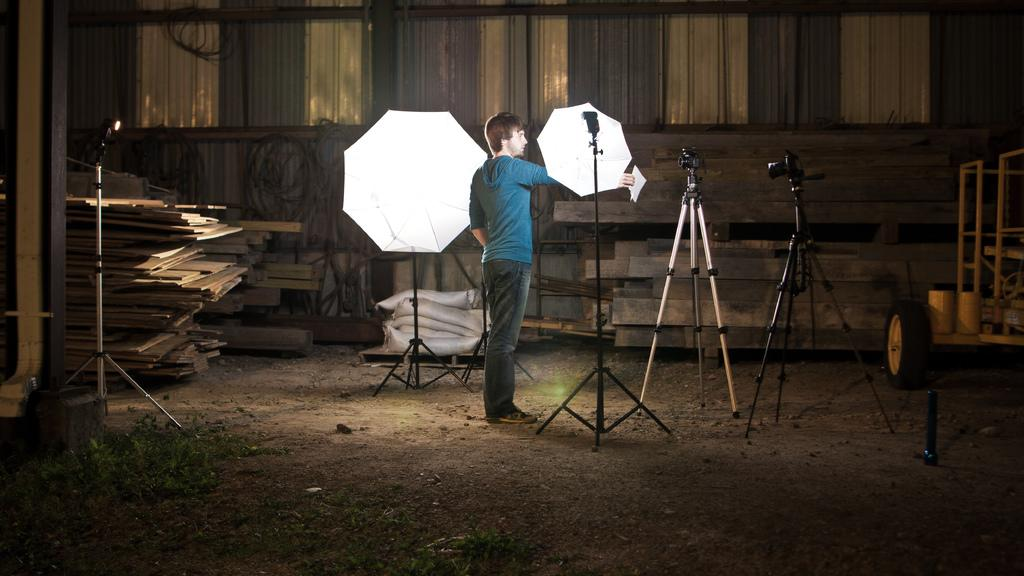What is the main subject of the image? There is a man standing in the image. What is the man wearing? The man is wearing clothes. What objects related to photography can be seen in the image? There are cameras, a stand, and a flash diffuser umbrella in the image. What type of surface is visible in the image? There are wooden sheets, grass, and sand in the image. What other objects can be seen in the image? There are tires in the image. What type of sofa can be seen in the image? There is no sofa present in the image. How many eggs are visible in the image? There are no eggs present in the image. 